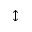<formula> <loc_0><loc_0><loc_500><loc_500>\updownarrow</formula> 